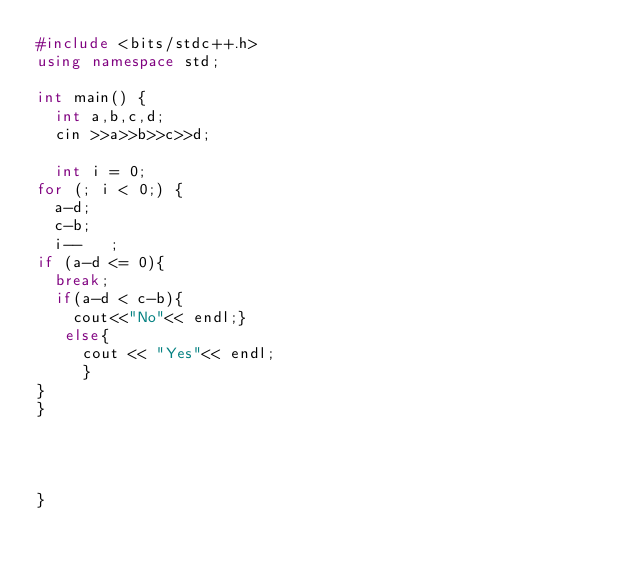Convert code to text. <code><loc_0><loc_0><loc_500><loc_500><_C++_>#include <bits/stdc++.h>
using namespace std;

int main() {
  int a,b,c,d;
  cin >>a>>b>>c>>d;
  
  int i = 0;
for (; i < 0;) {
  a-d;
  c-b;
  i--	;
if (a-d <= 0){
  break;
  if(a-d < c-b){
    cout<<"No"<< endl;}
   else{
     cout << "Yes"<< endl;
     }
}
}
    


    
}
</code> 